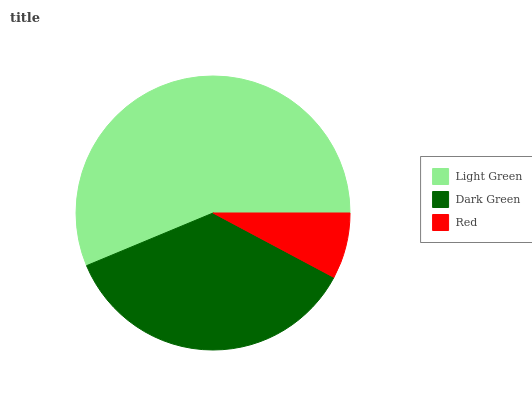Is Red the minimum?
Answer yes or no. Yes. Is Light Green the maximum?
Answer yes or no. Yes. Is Dark Green the minimum?
Answer yes or no. No. Is Dark Green the maximum?
Answer yes or no. No. Is Light Green greater than Dark Green?
Answer yes or no. Yes. Is Dark Green less than Light Green?
Answer yes or no. Yes. Is Dark Green greater than Light Green?
Answer yes or no. No. Is Light Green less than Dark Green?
Answer yes or no. No. Is Dark Green the high median?
Answer yes or no. Yes. Is Dark Green the low median?
Answer yes or no. Yes. Is Light Green the high median?
Answer yes or no. No. Is Light Green the low median?
Answer yes or no. No. 